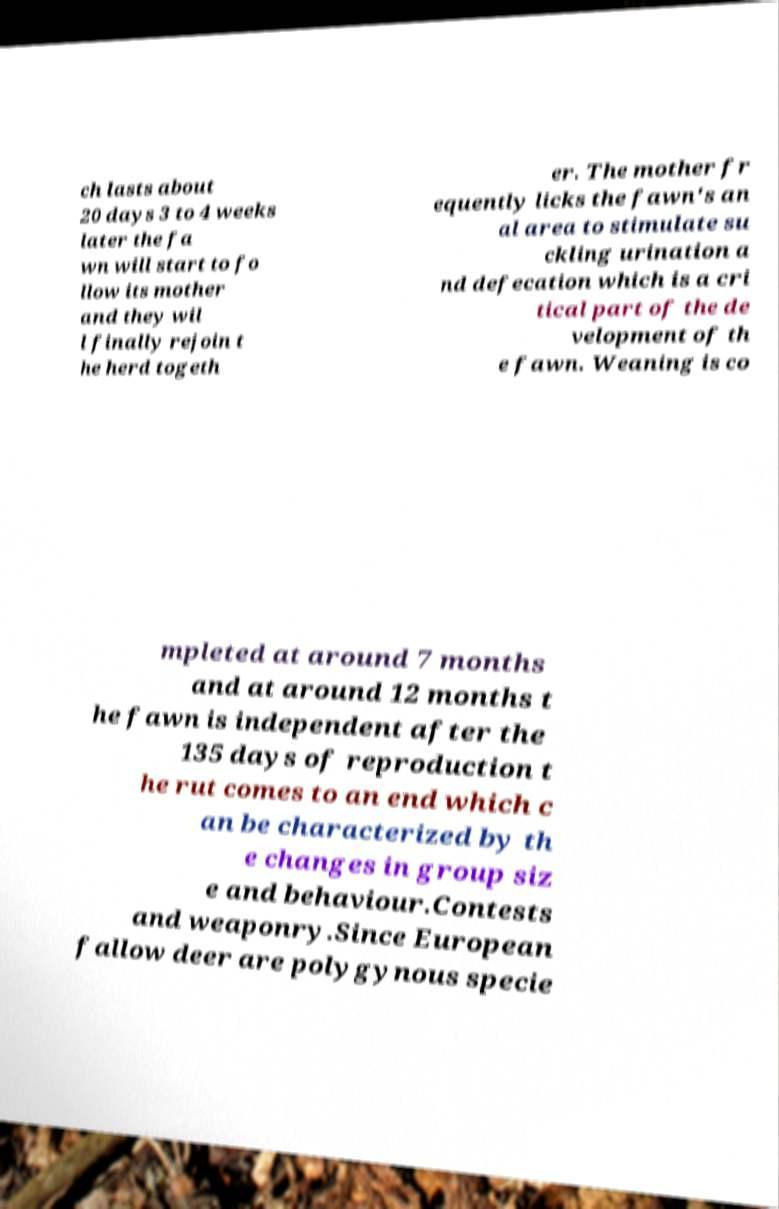Please read and relay the text visible in this image. What does it say? ch lasts about 20 days 3 to 4 weeks later the fa wn will start to fo llow its mother and they wil l finally rejoin t he herd togeth er. The mother fr equently licks the fawn's an al area to stimulate su ckling urination a nd defecation which is a cri tical part of the de velopment of th e fawn. Weaning is co mpleted at around 7 months and at around 12 months t he fawn is independent after the 135 days of reproduction t he rut comes to an end which c an be characterized by th e changes in group siz e and behaviour.Contests and weaponry.Since European fallow deer are polygynous specie 